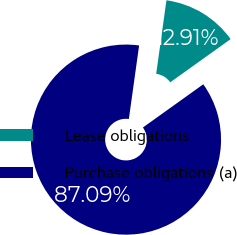Convert chart to OTSL. <chart><loc_0><loc_0><loc_500><loc_500><pie_chart><fcel>Lease obligations<fcel>Purchase obligations (a)<nl><fcel>12.91%<fcel>87.09%<nl></chart> 